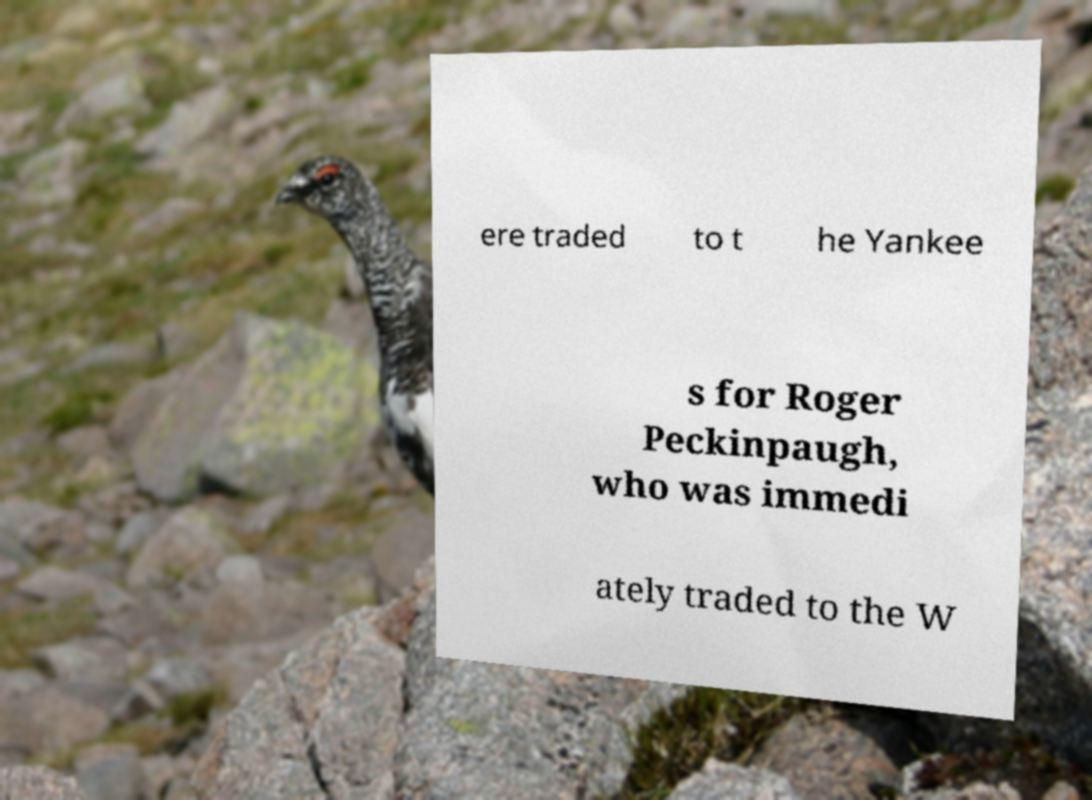Could you assist in decoding the text presented in this image and type it out clearly? ere traded to t he Yankee s for Roger Peckinpaugh, who was immedi ately traded to the W 